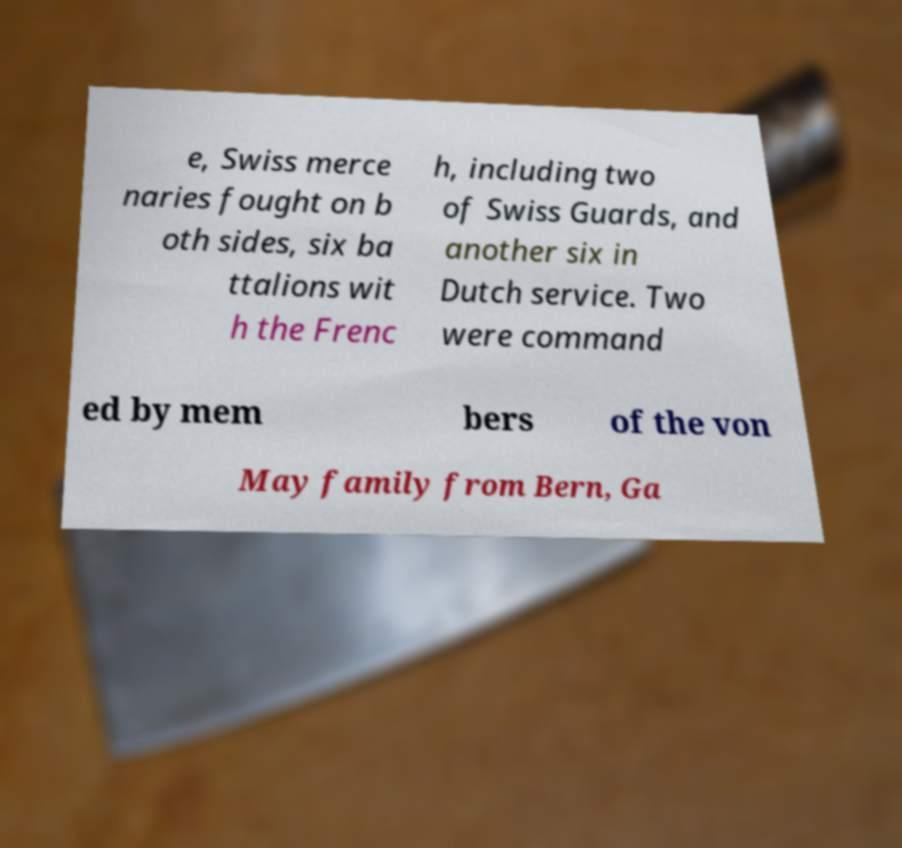For documentation purposes, I need the text within this image transcribed. Could you provide that? e, Swiss merce naries fought on b oth sides, six ba ttalions wit h the Frenc h, including two of Swiss Guards, and another six in Dutch service. Two were command ed by mem bers of the von May family from Bern, Ga 